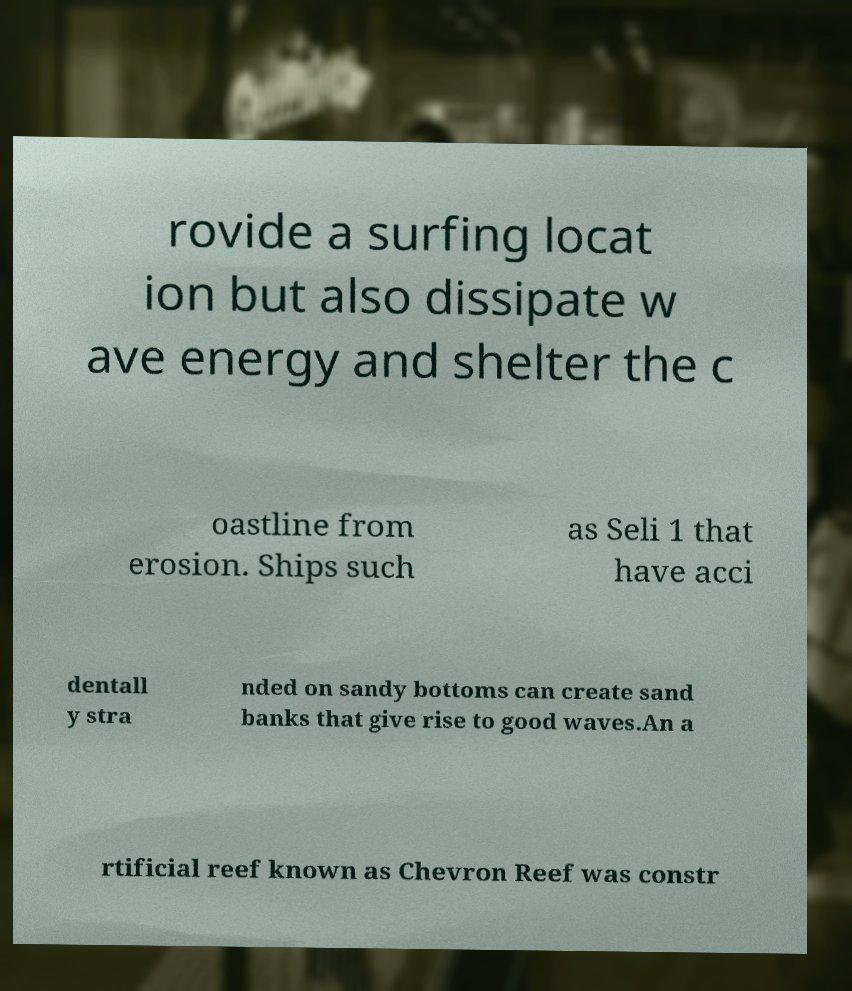I need the written content from this picture converted into text. Can you do that? rovide a surfing locat ion but also dissipate w ave energy and shelter the c oastline from erosion. Ships such as Seli 1 that have acci dentall y stra nded on sandy bottoms can create sand banks that give rise to good waves.An a rtificial reef known as Chevron Reef was constr 